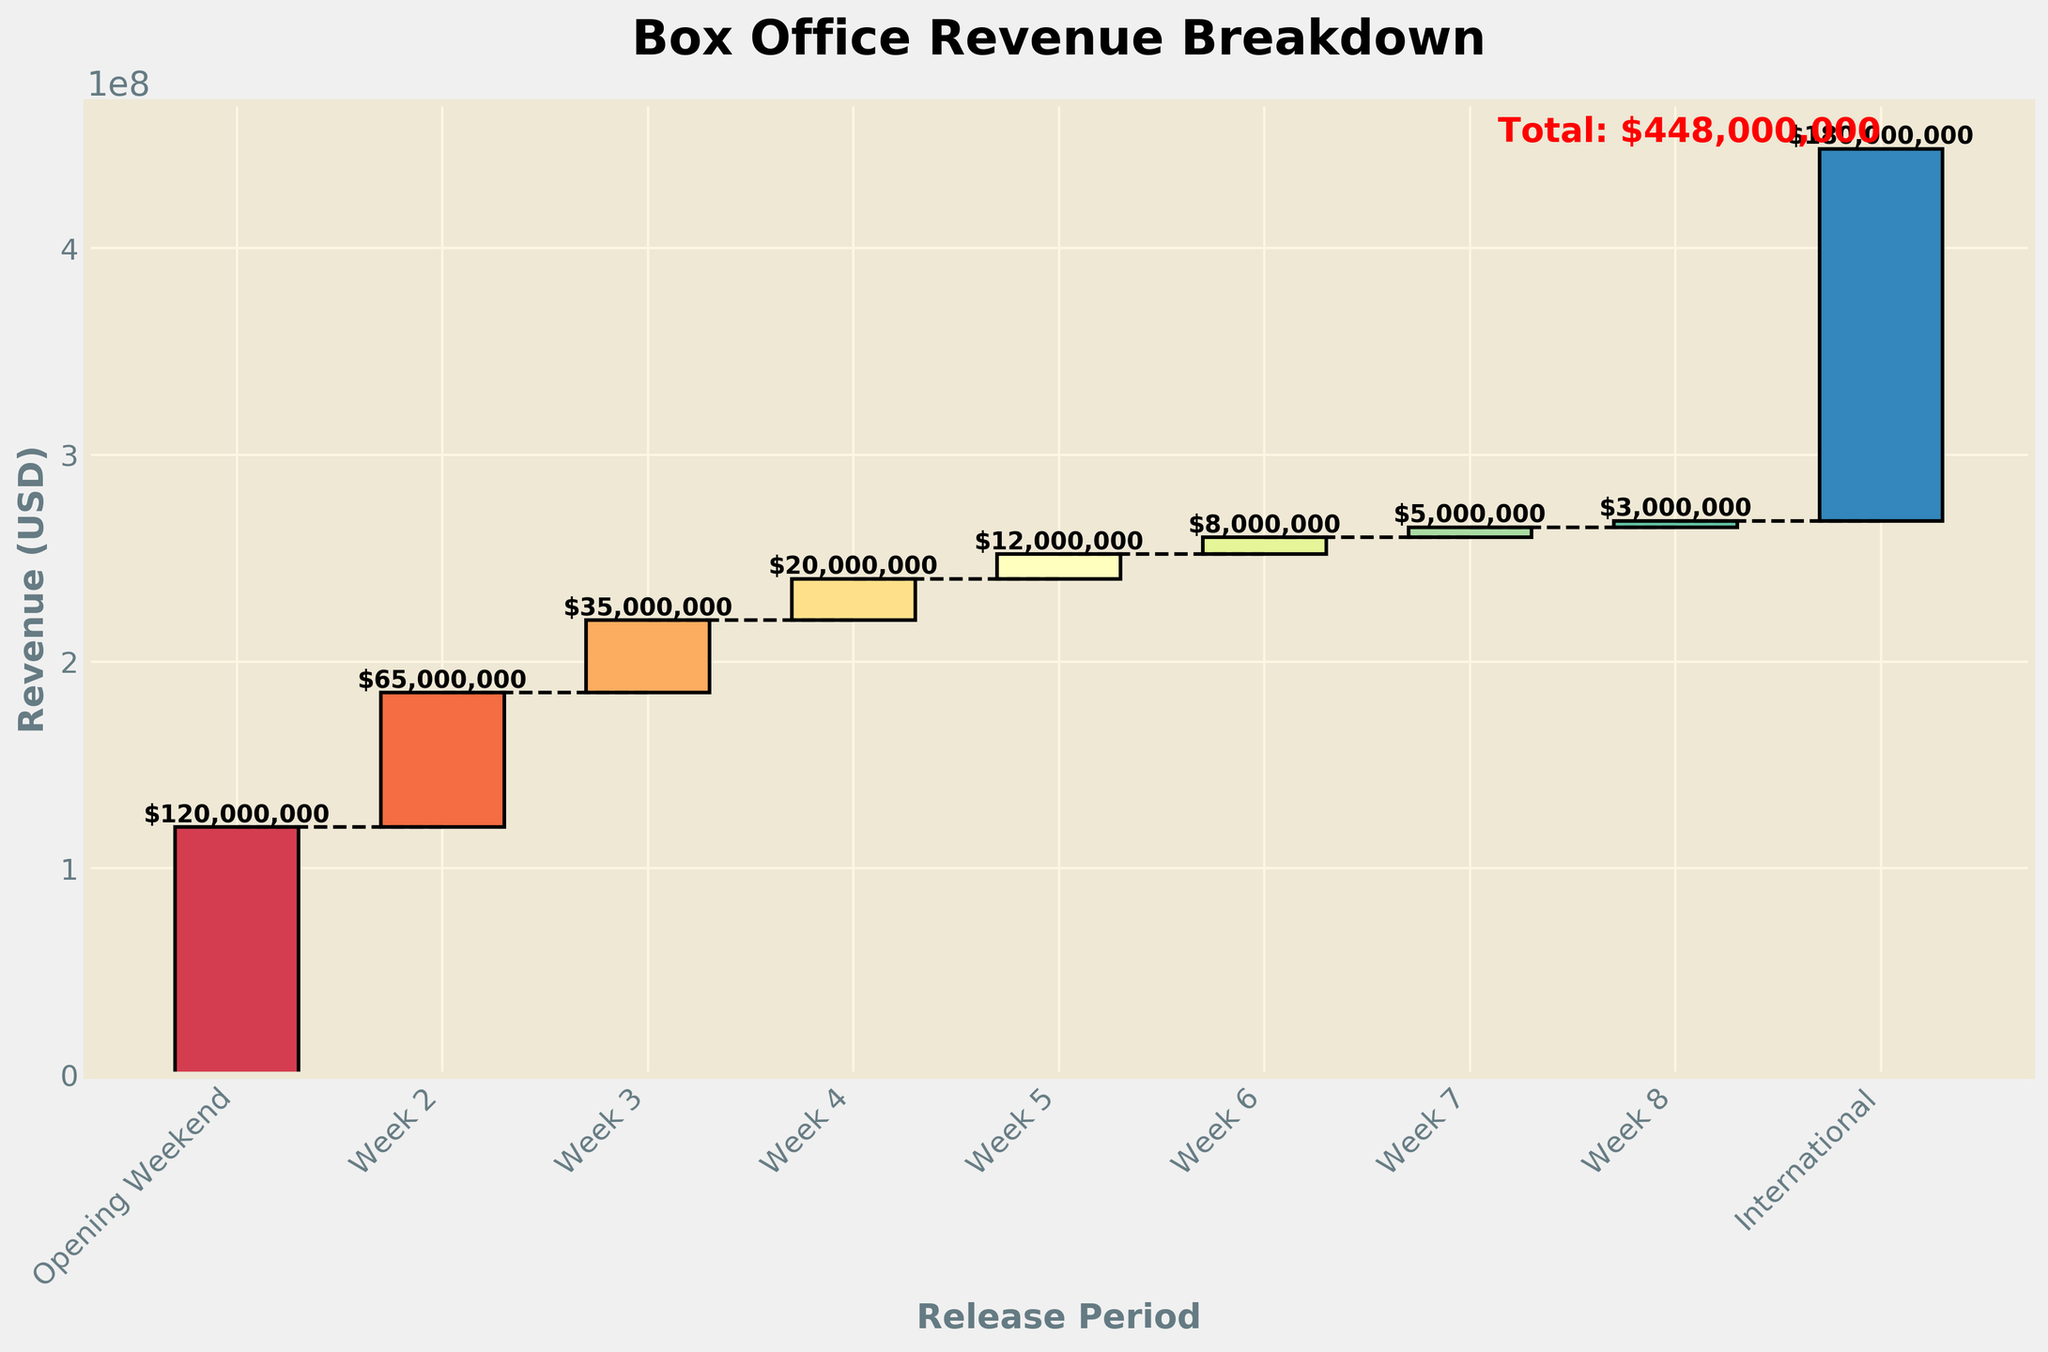What's the title of the figure? The title is usually found at the top of the figure. Here, it reads "Box Office Revenue Breakdown."
Answer: Box Office Revenue Breakdown What is the color of the bars used in the figure? The bars are colored using a spectrum of colors from a colormap, ranging from different shades like blues, greens, and reds.
Answer: Spectrum of colors How many release periods are represented in the chart? You can count the number of bars representing each release period in the chart. Excluding the total, there are 8 periods: Opening Weekend, Week 2, Week 3, Week 4, Week 5, Week 6, Week 7, and Week 8, plus International.
Answer: 9 What is the total revenue shown on the chart? The total revenue is indicated near the last bar, marked in red. The sum of all contributions adds up to $448,000,000.
Answer: $448,000,000 Which week had the highest revenue? The highest revenue will be represented by the tallest individual bar in the chart. The Opening Weekend bar is the tallest, signifying the highest revenue, which is $120,000,000.
Answer: Opening Weekend What’s the revenue for the second week? Locate the bar for Week 2 on the x-axis and read the height of the bar, which corresponds to the revenue. Week 2 generated $65,000,000.
Answer: $65,000,000 How much more revenue was made in the Opening Weekend compared to Week 4? Find the difference between the revenue of Opening Weekend ($120,000,000) and Week 4 ($20,000,000). $120,000,000 - $20,000,000 = $100,000,000
Answer: $100,000,000 What is the cumulative revenue after the third week? The cumulative revenue is the sum of revenues from the Opening Weekend, Week 2, and Week 3. $120,000,000 + $65,000,000 + $35,000,000 = $220,000,000
Answer: $220,000,000 Compare the revenue contributions of Week 5 and International markets. Which is higher and by how much? Week 5 contributed $12,000,000, whereas International markets contributed $180,000,000. The difference is $180,000,000 - $12,000,000 = $168,000,000. International markets had a higher contribution by $168,000,000.
Answer: International by $168,000,000 What trend do you observe in the domestic weekly revenue over the 8-week period? The trend indicated by the bars shows that domestic weekly revenue decreases over time, starting high at the Opening Weekend and then gradually dropping each successive week until Week 8. This is evident from the declining height of the bars from Opening Weekend to Week 8.
Answer: Decreasing trend 